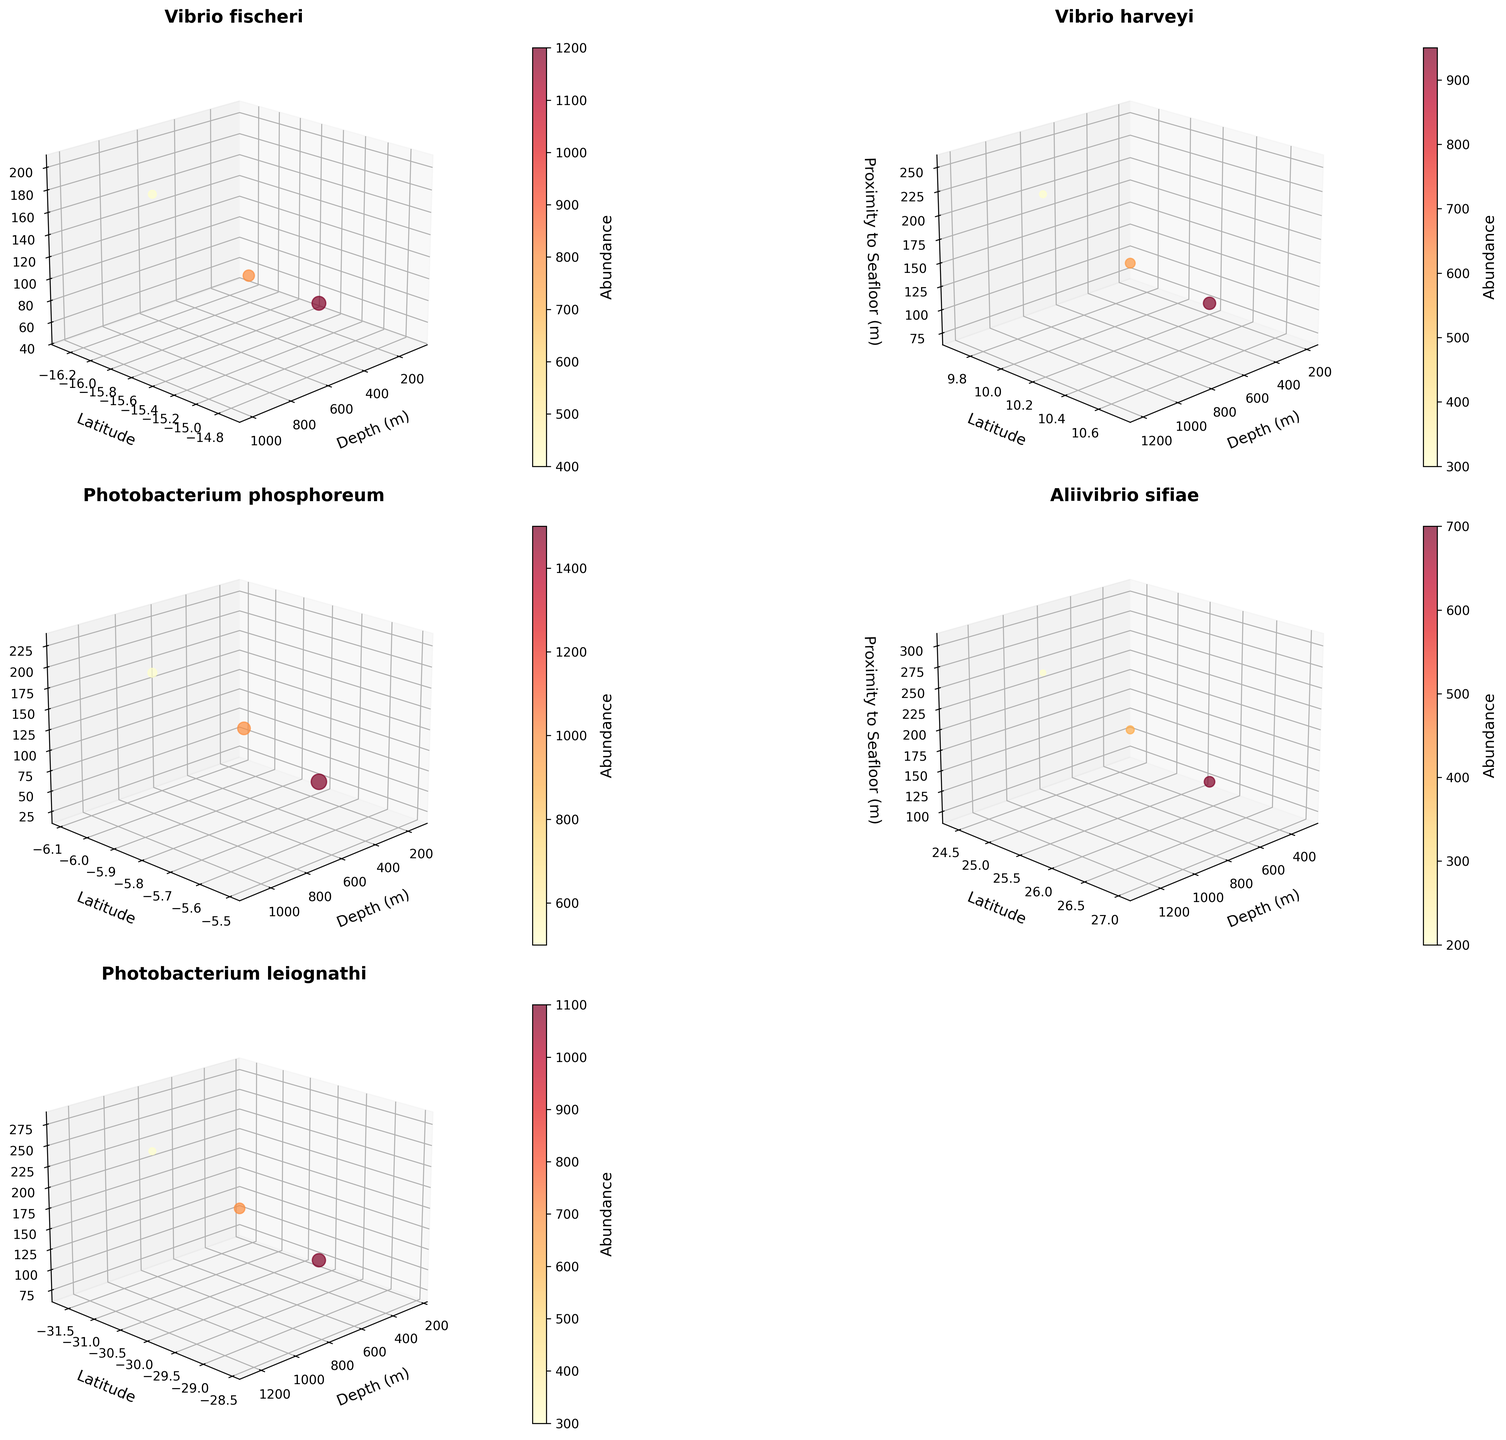Which species shows the highest abundance at 150 meters of depth? By looking at the graph for the species plotted at 150 meters, we can see that Photobacterium phosphoreum has the highest abundance.
Answer: Photobacterium phosphoreum What is the latitude range covered by Vibrio fischeri in the subplot? By analyzing the subplot for Vibrio fischeri, the latitude ranges from -15.5 to -15.5, a constant value.
Answer: -15.5 to -15.5 How does the abundance of Vibrio harveyi change with increasing depth? By inspecting the subplot for Vibrio harveyi, we observe that the abundance decreases as depth increases. The abundance at 200m is 950, at 700m is 600, and at 1200m is 300.
Answer: Decreases Which species has the most widespread proximity range to the seafloor? By examining all subplots, Photobacterium leiognathi and Aliivibrio sifiae have a proximity range from 25 to 300 meters.
Answer: Photobacterium leiognathi, Aliivibrio sifiae Does Photobacterium leiognathi show a similar abundance trend with depth compared to Vibrio fischeri? By comparing the subplots of Photobacterium leiognathi and Vibrio fischeri, it is evident that both species follow a similar trend of decreasing abundance with increasing depth.
Answer: Yes Which species has the lowest abundance at depths greater than 1000 meters? Examining the subplots for species with data points at depths greater than 1000 meters, we see Aliivibrio sifiae has the lowest recorded abundance of 200 at 1300 meters.
Answer: Aliivibrio sifiae Is there any significant variation in the color of data points for Photobacterium phosphoreum? In the subplot for Photobacterium phosphoreum, examining the color gradient which represents abundance, significant variations are indicated with values ranging from 1500 to 500.
Answer: Yes Which species shows the steepest decline in abundance per unit depth? By comparing the differences in abundance with respect to depth for each species, Aliivibrio sifiae shows the steepest decline, dropping from 700 at 300 meters to 200 at 1300 meters.
Answer: Aliivibrio sifiae Are there any species that have similar distributions along both latitude and proximity to seafloor? Observing the subplots, it's clear that Vibrio harveyi, Photobacterium leiognathi, and Aliivibrio sifiae have relatively similar distributions in both latitude and proximity to seafloor, covering ranges of (-30.1 to 25.7) for latitude and (50 to 300) for proximity.
Answer: Yes 